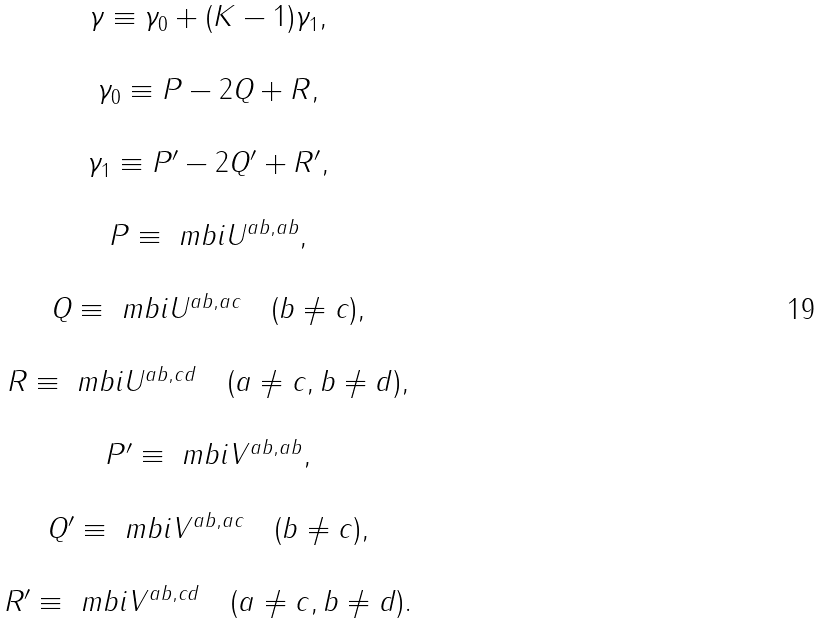<formula> <loc_0><loc_0><loc_500><loc_500>\begin{array} { c } \gamma \equiv \gamma _ { 0 } + ( K - 1 ) \gamma _ { 1 } , \\ \\ \gamma _ { 0 } \equiv P - 2 Q + R , \\ \\ \gamma _ { 1 } \equiv P ^ { \prime } - 2 Q ^ { \prime } + R ^ { \prime } , \\ \\ P \equiv \ m b i { U } ^ { a b , a b } , \\ \\ Q \equiv \ m b i { U } ^ { a b , a c } \quad ( b \neq c ) , \\ \\ R \equiv \ m b i { U } ^ { a b , c d } \quad ( a \neq c , b \neq d ) , \\ \\ P ^ { \prime } \equiv \ m b i { V } ^ { a b , a b } , \\ \\ Q ^ { \prime } \equiv \ m b i { V } ^ { a b , a c } \quad ( b \neq c ) , \\ \\ R ^ { \prime } \equiv \ m b i { V } ^ { a b , c d } \quad ( a \neq c , b \neq d ) . \end{array}</formula> 